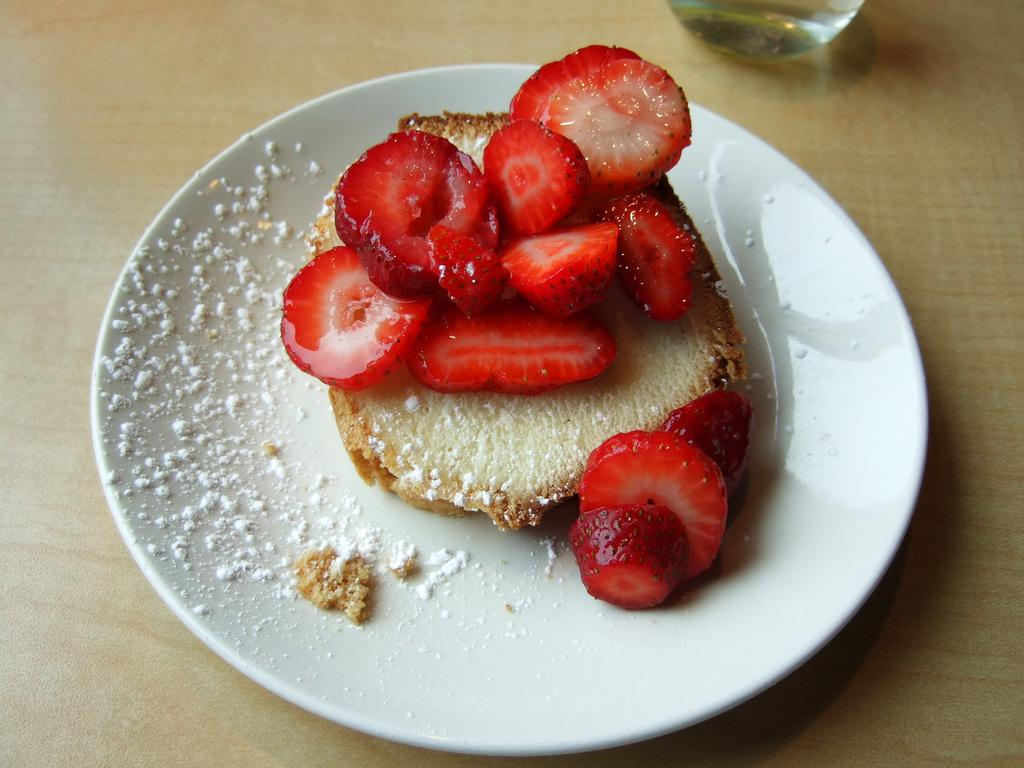What type of fruit is in the image? There is a strawberry in the image. What type of food is also in the image? There is a bread piece in the image. What color is the plate that holds the strawberry and bread piece? The plate is white in color. What is the color of the table on which the plate is placed? The table is brown in color. How many women are helping to prepare the meal in the image? There are no women or any indication of meal preparation in the image; it only shows a strawberry, bread piece, and a plate on a table. 